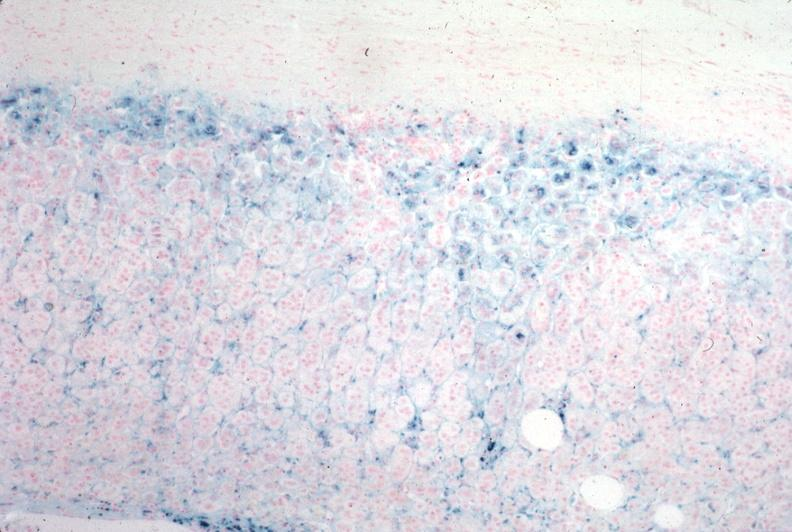s adrenal present?
Answer the question using a single word or phrase. Yes 